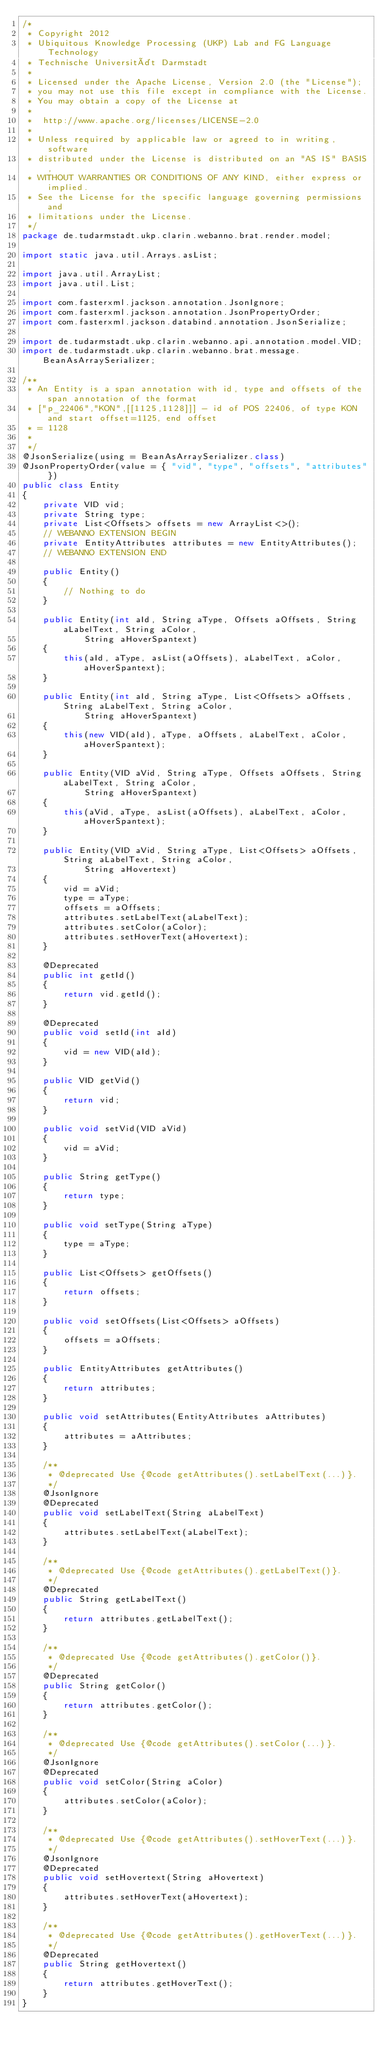<code> <loc_0><loc_0><loc_500><loc_500><_Java_>/*
 * Copyright 2012
 * Ubiquitous Knowledge Processing (UKP) Lab and FG Language Technology
 * Technische Universität Darmstadt
 * 
 * Licensed under the Apache License, Version 2.0 (the "License");
 * you may not use this file except in compliance with the License.
 * You may obtain a copy of the License at
 *  
 *  http://www.apache.org/licenses/LICENSE-2.0
 * 
 * Unless required by applicable law or agreed to in writing, software
 * distributed under the License is distributed on an "AS IS" BASIS,
 * WITHOUT WARRANTIES OR CONDITIONS OF ANY KIND, either express or implied.
 * See the License for the specific language governing permissions and
 * limitations under the License.
 */
package de.tudarmstadt.ukp.clarin.webanno.brat.render.model;

import static java.util.Arrays.asList;

import java.util.ArrayList;
import java.util.List;

import com.fasterxml.jackson.annotation.JsonIgnore;
import com.fasterxml.jackson.annotation.JsonPropertyOrder;
import com.fasterxml.jackson.databind.annotation.JsonSerialize;

import de.tudarmstadt.ukp.clarin.webanno.api.annotation.model.VID;
import de.tudarmstadt.ukp.clarin.webanno.brat.message.BeanAsArraySerializer;

/**
 * An Entity is a span annotation with id, type and offsets of the span annotation of the format
 * ["p_22406","KON",[[1125,1128]]] - id of POS 22406, of type KON and start offset=1125, end offset
 * = 1128
 *
 */
@JsonSerialize(using = BeanAsArraySerializer.class)
@JsonPropertyOrder(value = { "vid", "type", "offsets", "attributes" })
public class Entity
{
    private VID vid;
    private String type;
    private List<Offsets> offsets = new ArrayList<>();
    // WEBANNO EXTENSION BEGIN
    private EntityAttributes attributes = new EntityAttributes();
    // WEBANNO EXTENSION END

    public Entity()
    {
        // Nothing to do
    }

    public Entity(int aId, String aType, Offsets aOffsets, String aLabelText, String aColor,
            String aHoverSpantext)
    {
        this(aId, aType, asList(aOffsets), aLabelText, aColor, aHoverSpantext);
    }

    public Entity(int aId, String aType, List<Offsets> aOffsets, String aLabelText, String aColor,
            String aHoverSpantext)
    {
        this(new VID(aId), aType, aOffsets, aLabelText, aColor, aHoverSpantext);
    }

    public Entity(VID aVid, String aType, Offsets aOffsets, String aLabelText, String aColor,
            String aHoverSpantext)
    {
        this(aVid, aType, asList(aOffsets), aLabelText, aColor, aHoverSpantext);
    }

    public Entity(VID aVid, String aType, List<Offsets> aOffsets, String aLabelText, String aColor,
            String aHovertext)
    {
        vid = aVid;
        type = aType;
        offsets = aOffsets;
        attributes.setLabelText(aLabelText);
        attributes.setColor(aColor);
        attributes.setHoverText(aHovertext);
    }

    @Deprecated
    public int getId()
    {
        return vid.getId();
    }

    @Deprecated
    public void setId(int aId)
    {
        vid = new VID(aId);
    }

    public VID getVid()
    {
        return vid;
    }

    public void setVid(VID aVid)
    {
        vid = aVid;
    }

    public String getType()
    {
        return type;
    }

    public void setType(String aType)
    {
        type = aType;
    }

    public List<Offsets> getOffsets()
    {
        return offsets;
    }

    public void setOffsets(List<Offsets> aOffsets)
    {
        offsets = aOffsets;
    }
    
    public EntityAttributes getAttributes()
    {
        return attributes;
    }
    
    public void setAttributes(EntityAttributes aAttributes)
    {
        attributes = aAttributes;
    }

    /**
     * @deprecated Use {@code getAttributes().setLabelText(...)}.
     */
    @JsonIgnore
    @Deprecated
    public void setLabelText(String aLabelText)
    {
        attributes.setLabelText(aLabelText);
    }

    /**
     * @deprecated Use {@code getAttributes().getLabelText()}.
     */
    @Deprecated
    public String getLabelText()
    {
        return attributes.getLabelText();
    }

    /**
     * @deprecated Use {@code getAttributes().getColor()}.
     */
    @Deprecated
    public String getColor()
    {
        return attributes.getColor();
    }

    /**
     * @deprecated Use {@code getAttributes().setColor(...)}.
     */
    @JsonIgnore
    @Deprecated
    public void setColor(String aColor)
    {
        attributes.setColor(aColor);
    }
    
    /**
     * @deprecated Use {@code getAttributes().setHoverText(...)}.
     */
    @JsonIgnore
    @Deprecated
    public void setHovertext(String aHovertext)
    {
        attributes.setHoverText(aHovertext);
    }

    /**
     * @deprecated Use {@code getAttributes().getHoverText(...)}.
     */
    @Deprecated
    public String getHovertext()
    {
        return attributes.getHoverText();
    }
}
</code> 